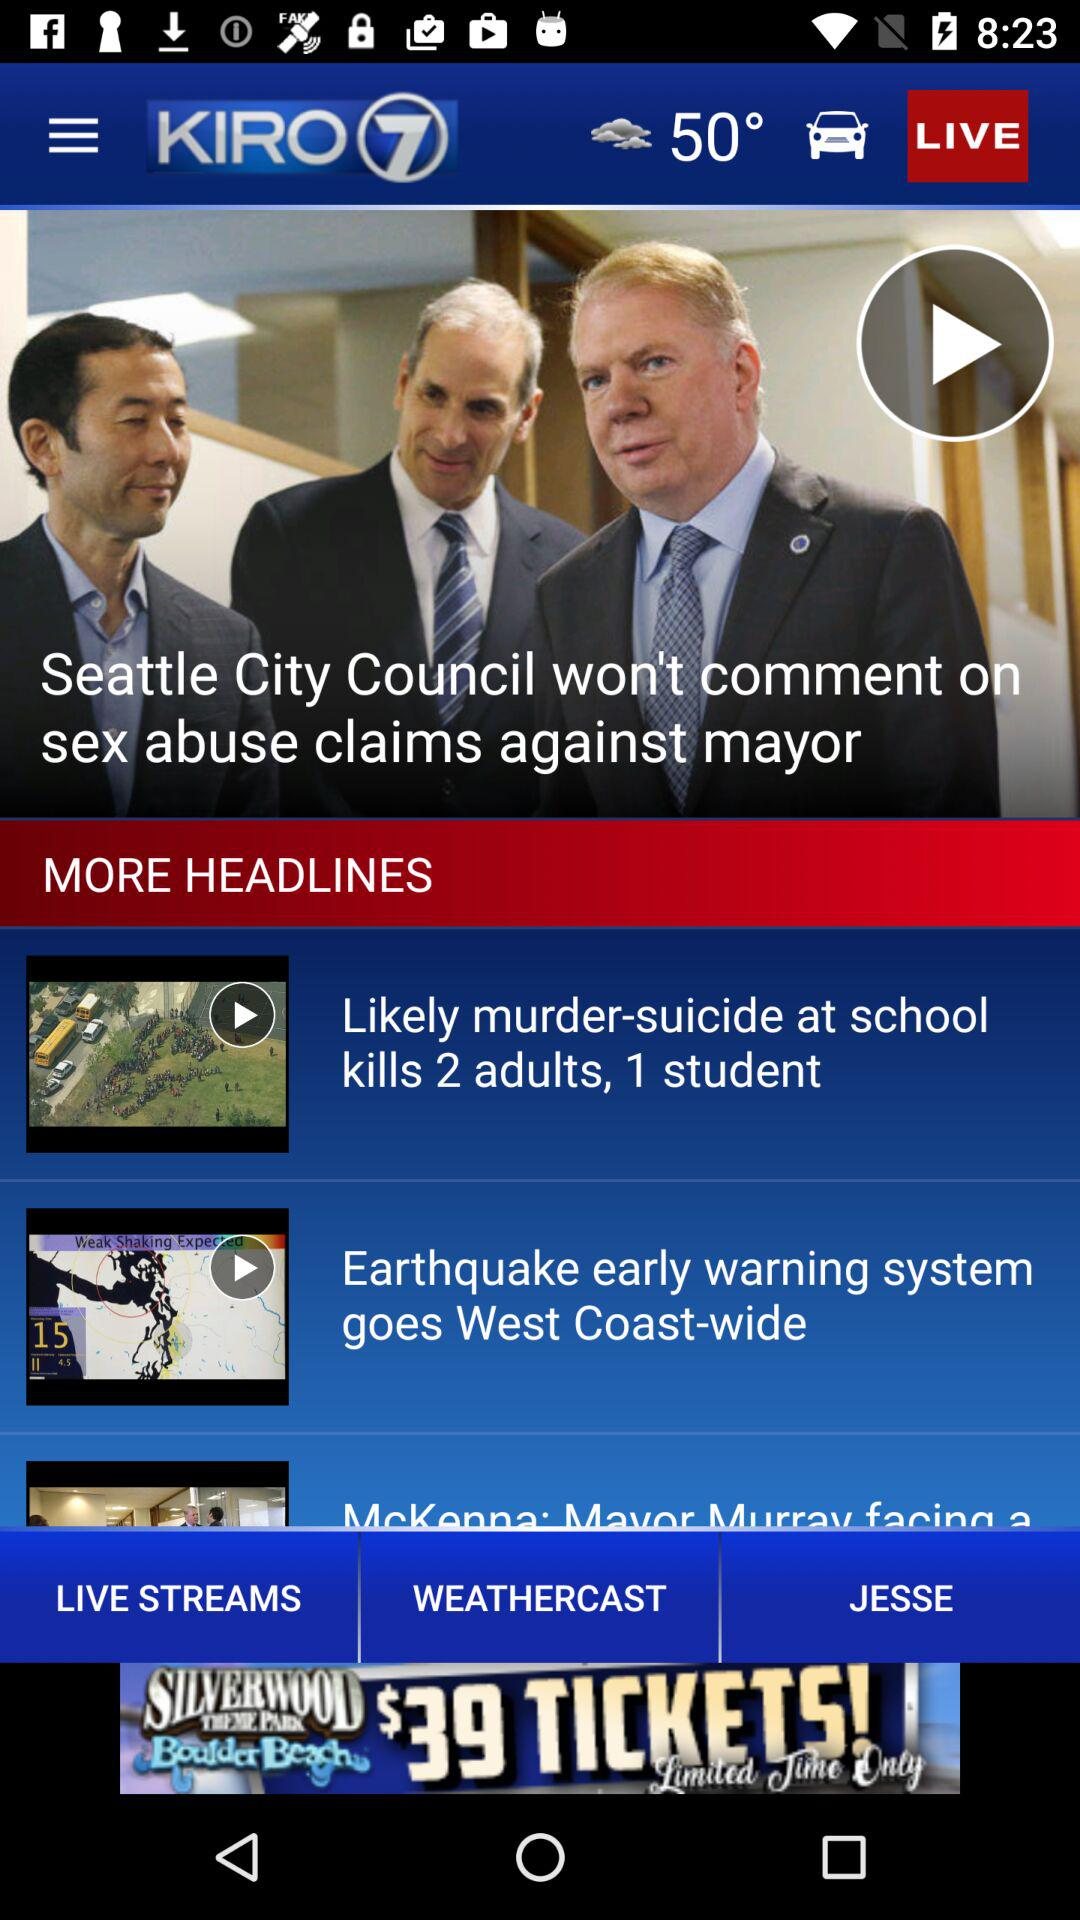What are the headlines given on the screen? The headlines given on the screen are "Seattle City Council won't comment on sex abuse claims against mayor", "Likely murder-suicide at school kills 2 adults, 1 student" and "Earthquake early warning system goes West Coast-wide". 